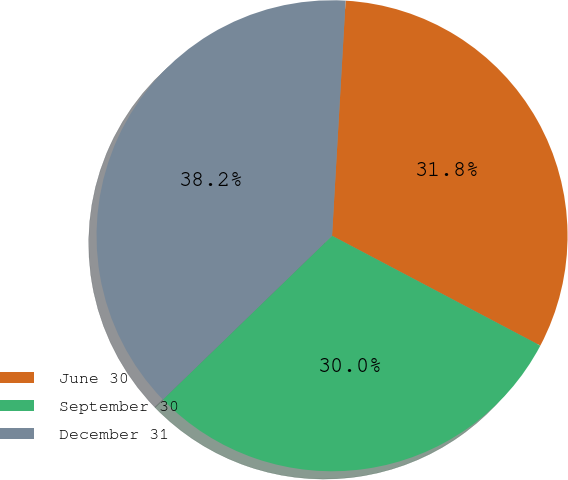Convert chart. <chart><loc_0><loc_0><loc_500><loc_500><pie_chart><fcel>June 30<fcel>September 30<fcel>December 31<nl><fcel>31.81%<fcel>30.03%<fcel>38.16%<nl></chart> 